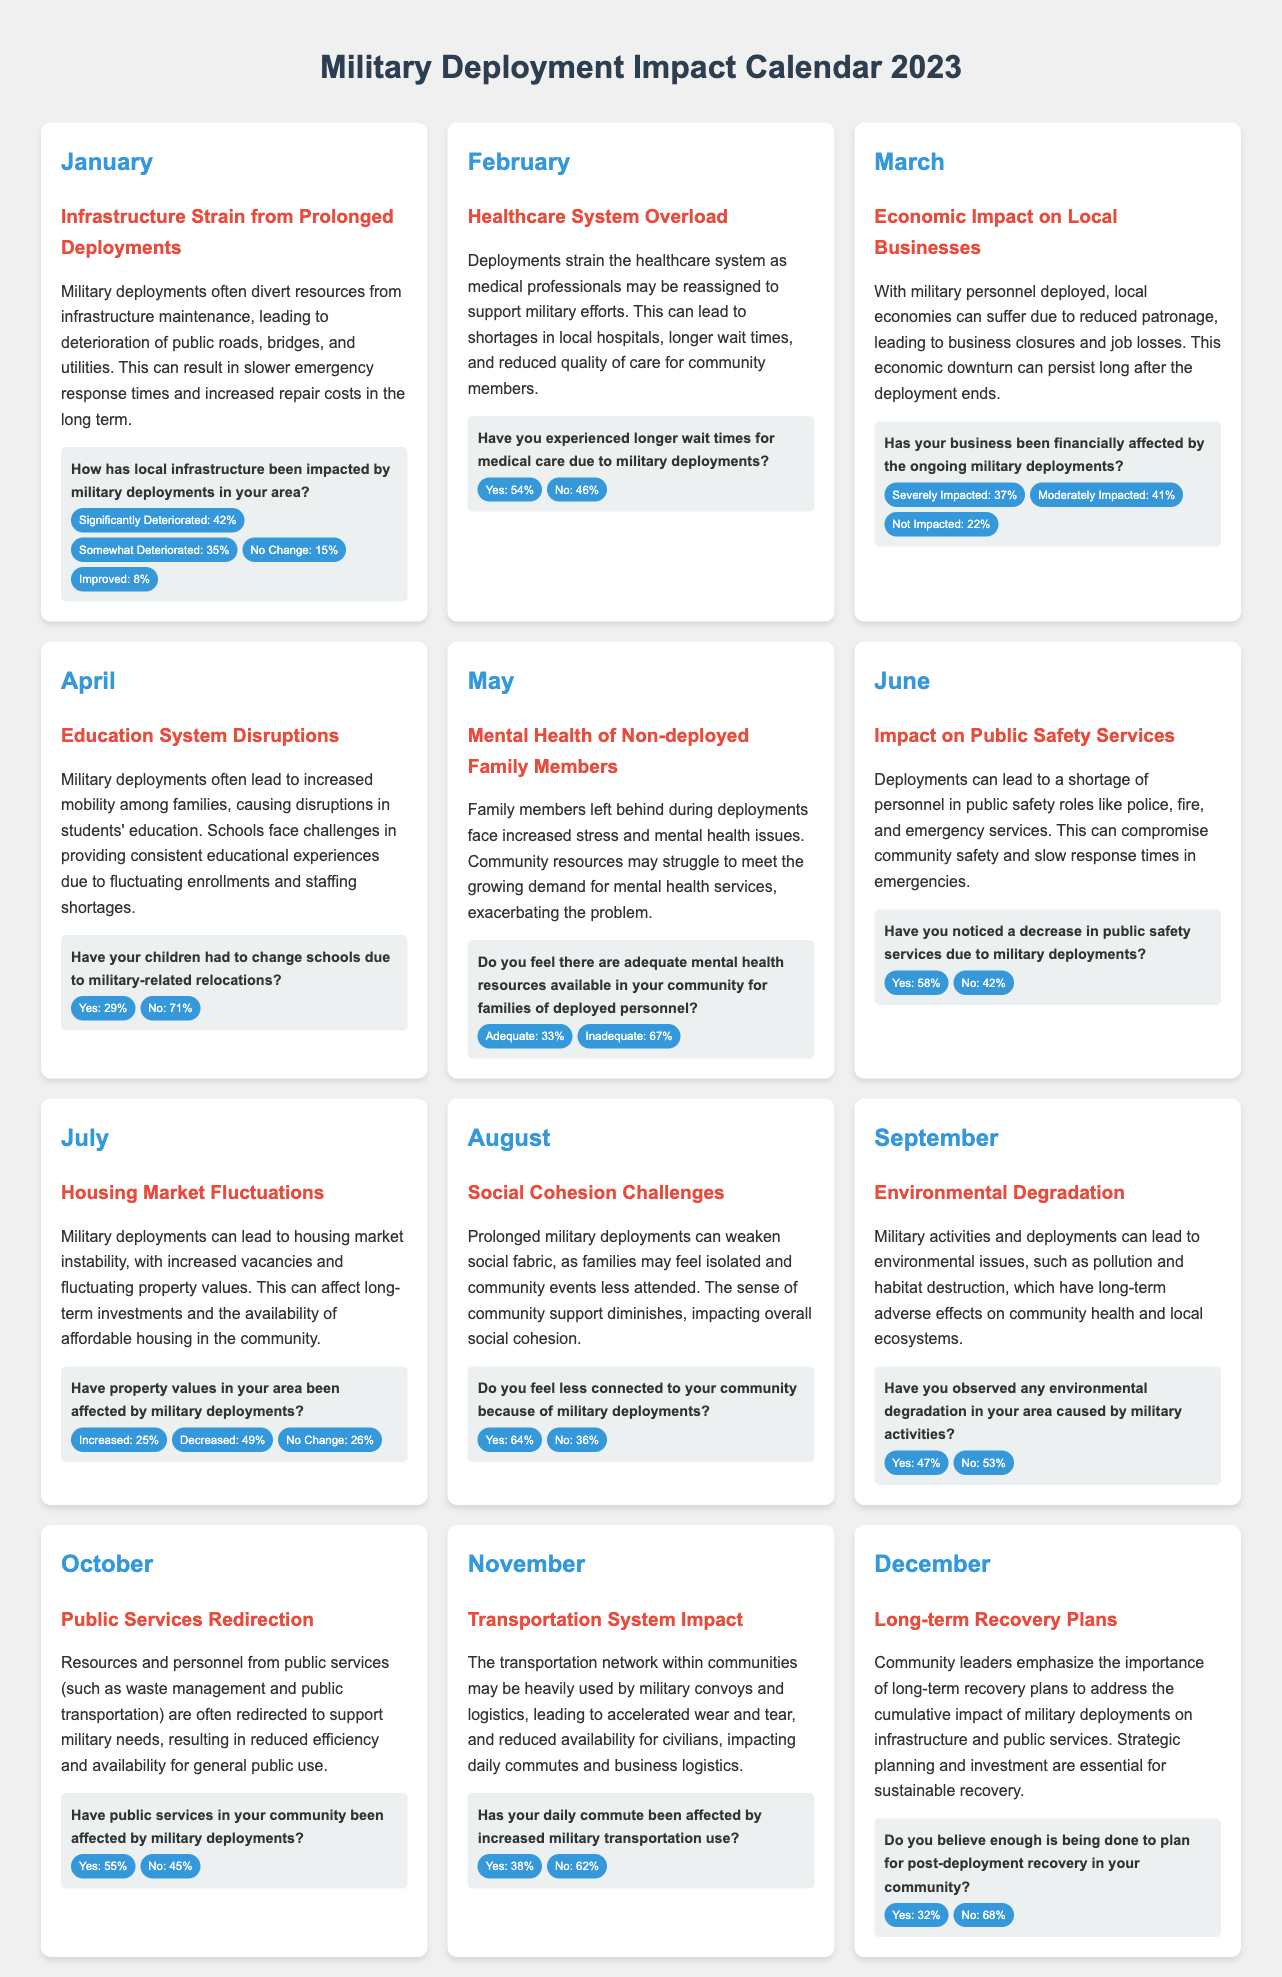What is the percentage of respondents who feel local infrastructure has significantly deteriorated? The document states that 42% of respondents reported that local infrastructure has significantly deteriorated due to military deployments.
Answer: 42% What is the primary healthcare system issue highlighted in February? February discusses that healthcare systems face overload due to medical professionals being reassigned for military efforts, leading to longer wait times and reduced care.
Answer: Healthcare system overload What percentage of businesses reported being severely impacted in March? In March, 37% of businesses indicated they were severely impacted by ongoing military deployments.
Answer: 37% How many respondents have noticed a decrease in public safety services in June? June indicates that 58% of respondents noticed a decrease in public safety services due to military deployments.
Answer: 58% What question was asked in May regarding mental health resources? The survey question in May asked if adequate mental health resources were available in the community for families of deployed personnel.
Answer: Adequate mental health resources Which month focuses on transportation system impact? The document's November section focuses on the impact of military transportation on the daily commute and logistics.
Answer: November What percentage of respondents believe that planning for post-deployment recovery is inadequate? According to December's survey, 68% believe that not enough is being done to plan for post-deployment recovery.
Answer: 68% Which month reported about the environmental degradation due to military activities? September is the month that discusses environmental degradation caused by military activities.
Answer: September What is the topic of discussion in April? The topic in April is the disruptions in the education system due to military deployments and relocations.
Answer: Education system disruptions 